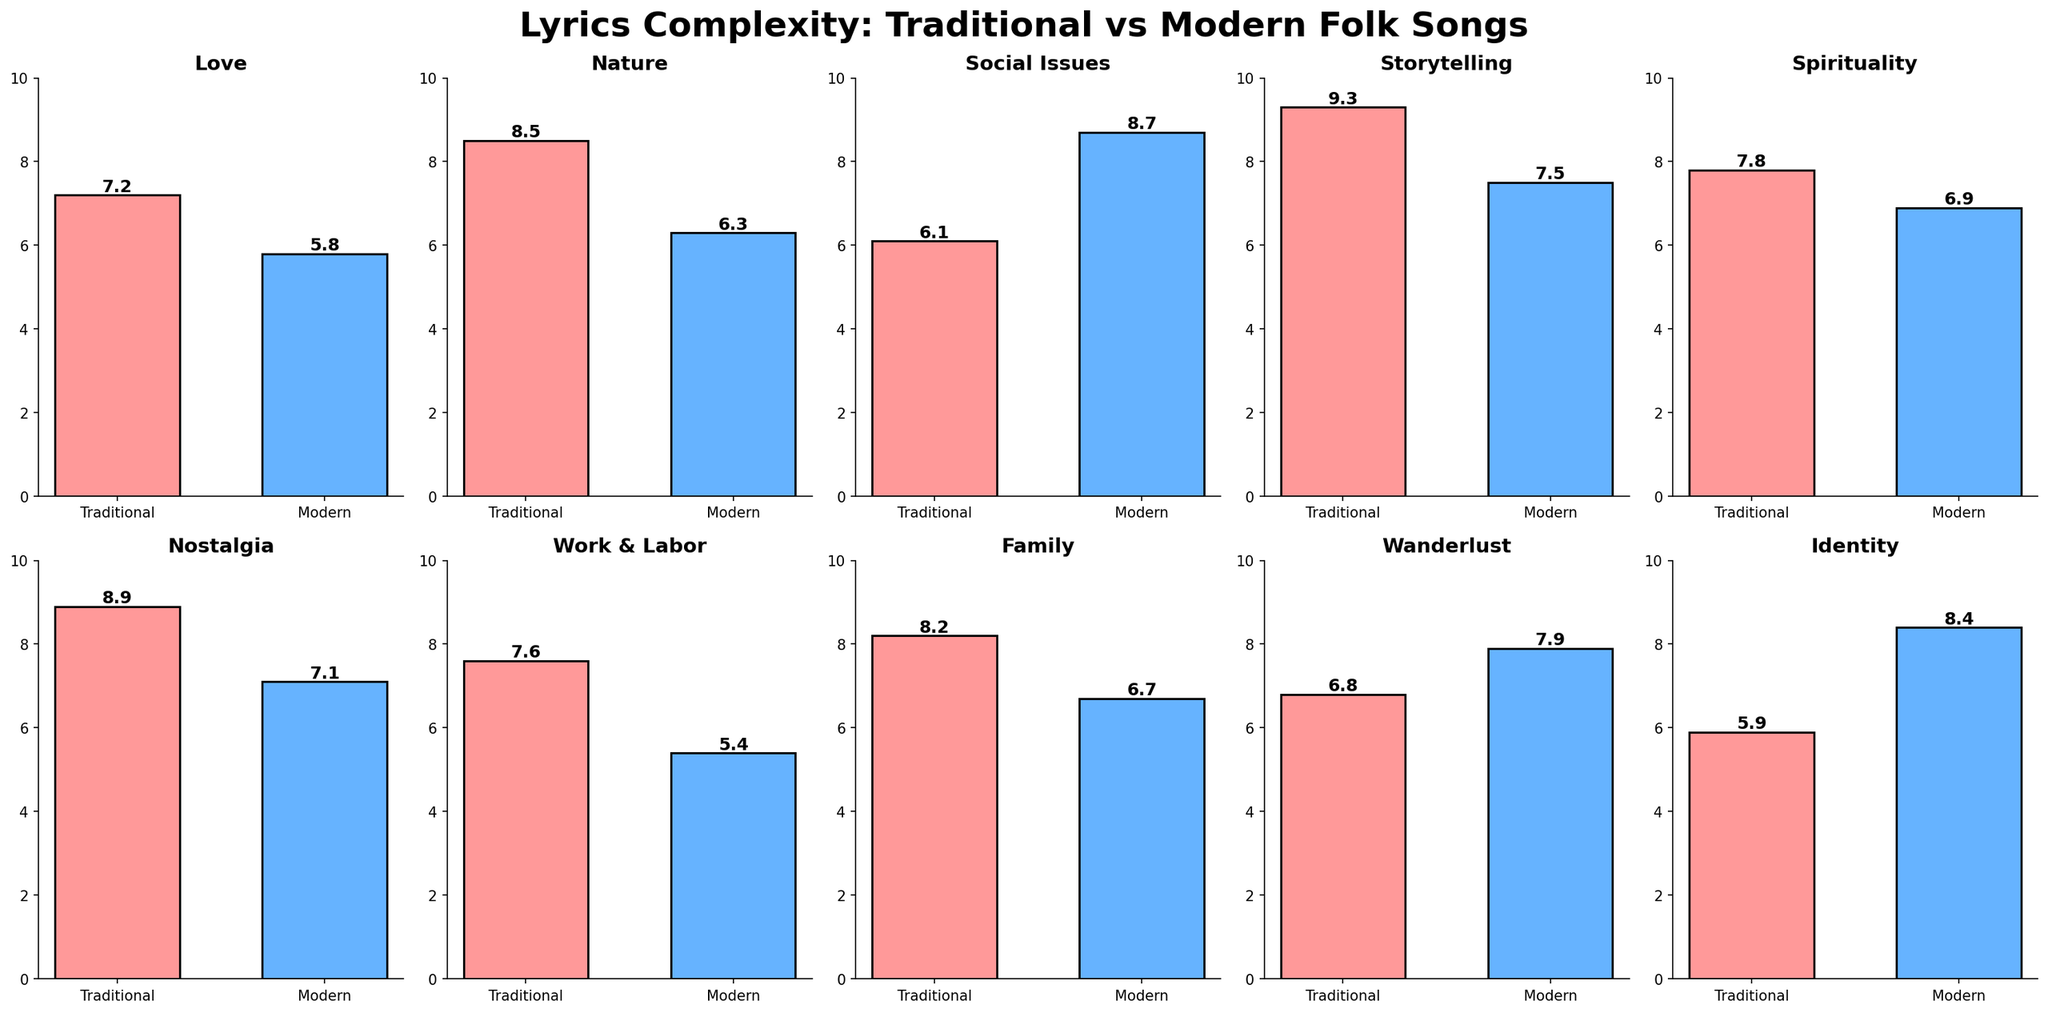What is the title of the figure? The title of the figure is usually the largest and boldest text at the top of the figure, and it is meant to summarize the main focus of the plot.
Answer: Lyrics Complexity: Traditional vs Modern Folk Songs Which theme has the highest traditional lyrics complexity? To find the theme with the highest complexity in traditional lyrics, look for the highest bar in the traditional category across all the subplots. In this case, the highest bar appears in the "Storytelling" theme subplot.
Answer: Storytelling Which theme shows a higher complexity in modern lyrics compared to traditional lyrics? To find this answer, examine each subplot and see where the modern bar is taller than the traditional bar. The "Social Issues", "Wanderlust", and "Identity" themes have taller modern bars.
Answer: Social Issues, Wanderlust, Identity What is the complexity difference in the "Love" theme between traditional and modern folk songs? To calculate the difference, subtract the modern complexity from the traditional complexity for the "Love" theme subplot. This would be 7.2 (Traditional) - 5.8 (Modern).
Answer: 1.4 In which two themes is the complexity of modern folk songs exactly 7.1? Find the subplots where the modern folk song bars are labeled 7.1, which are "Nostalgia" and no other subplot.
Answer: Nostalgia How many subplots are there in total? Count the total number of small individual subplots in the figure grid. There are 2 rows and 5 columns, so 2 * 5 equals 10.
Answer: 10 What is the average complexity for modern folk songs across all themes? To find the average, sum all the complexity values for modern folk songs and divide by the number of themes. (5.8 + 6.3 + 8.7 + 7.5 + 6.9 + 7.1 + 5.4 + 6.7 + 7.9 + 8.4) / 10 = 70.7 / 10.
Answer: 7.1 Which theme has the smallest difference in complexity between traditional and modern folk songs, and what is that difference? Find the themes where the difference between traditional and modern complexity is the smallest. Calculate these differences for all subplots and compare them: Love (1.4), Nature (2.2), Social Issues (-2.6), Storytelling (1.8), Spirituality (0.9), Nostalgia (1.8), Work & Labor (2.2), Family (1.5), Wanderlust (-1.1), Identity (-2.5). The smallest absolute difference is in Spirituality.
Answer: Spirituality, 0.9 Between the themes "Work & Labor" and "Family," which one has a greater complexity in traditional folk songs? Compare the heights of the bars in the "Work & Labor" and "Family" subplots under the traditional category. "Family" has a bar of 8.2, and "Work & Labor" has a bar of 7.6.
Answer: Family Which theme has the lowest complexity score for traditional folk songs and what is the value? Look for the smallest bar in the traditional category across all subplots. The "Identity" theme has the lowest traditional complexity value.
Answer: Identity, 5.9 